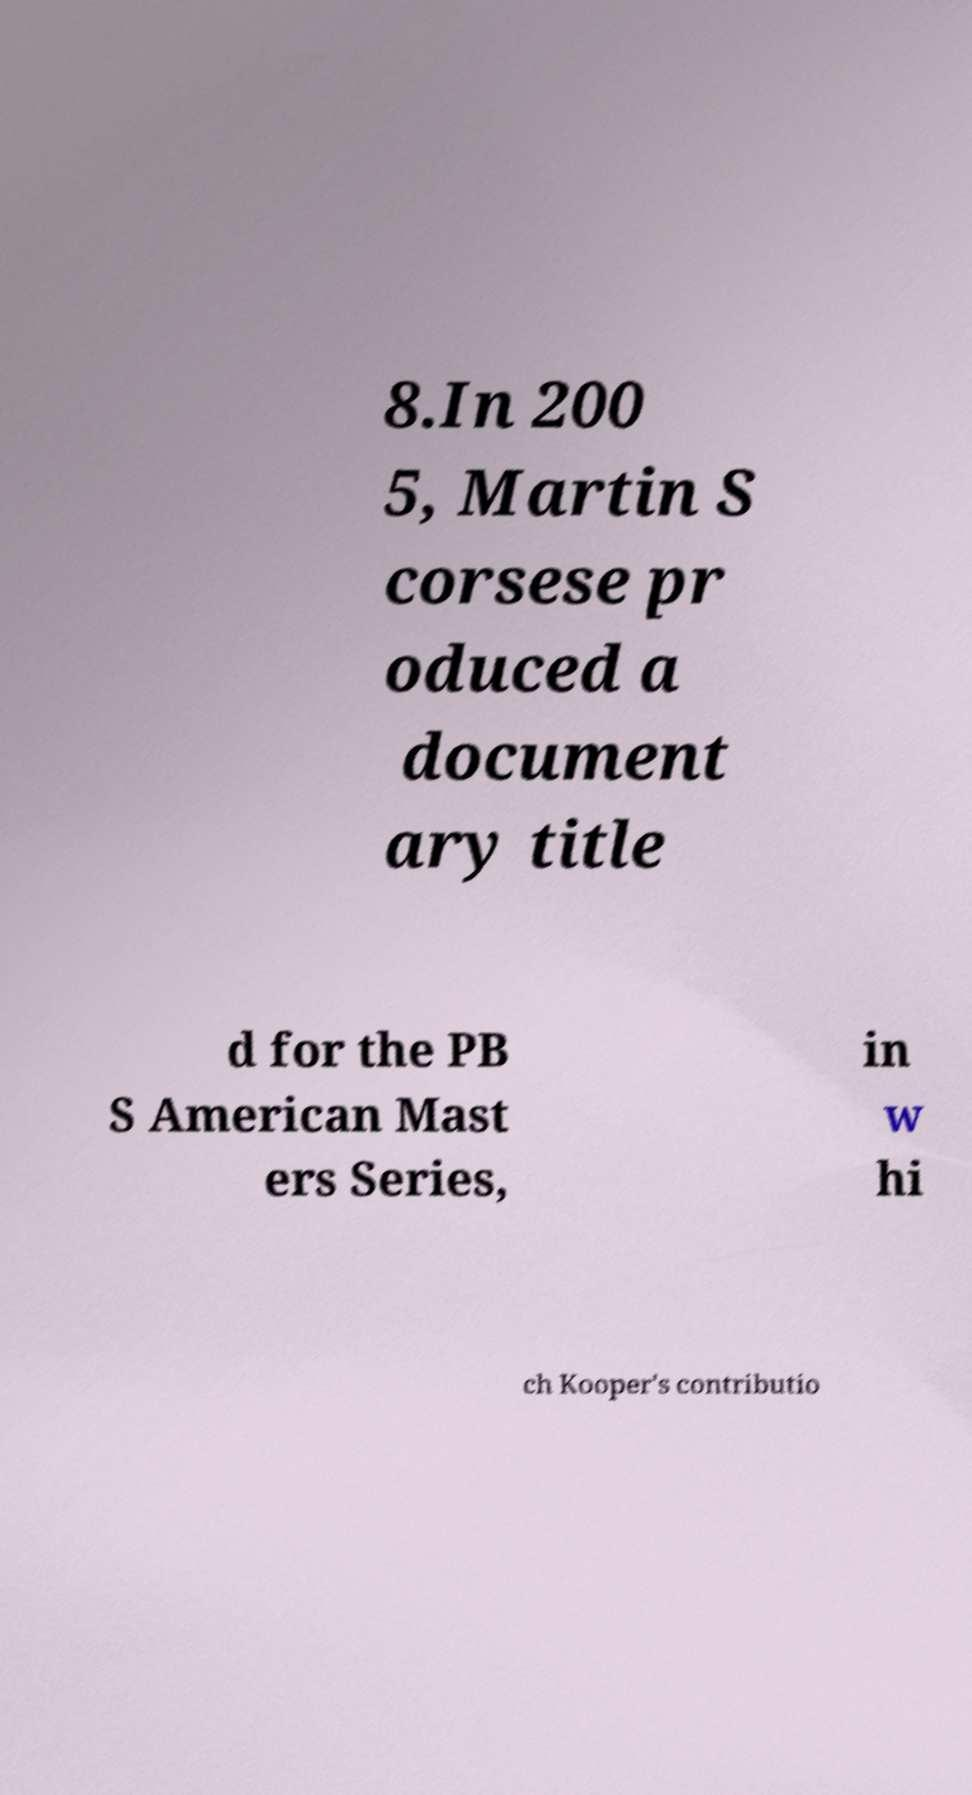What messages or text are displayed in this image? I need them in a readable, typed format. 8.In 200 5, Martin S corsese pr oduced a document ary title d for the PB S American Mast ers Series, in w hi ch Kooper's contributio 